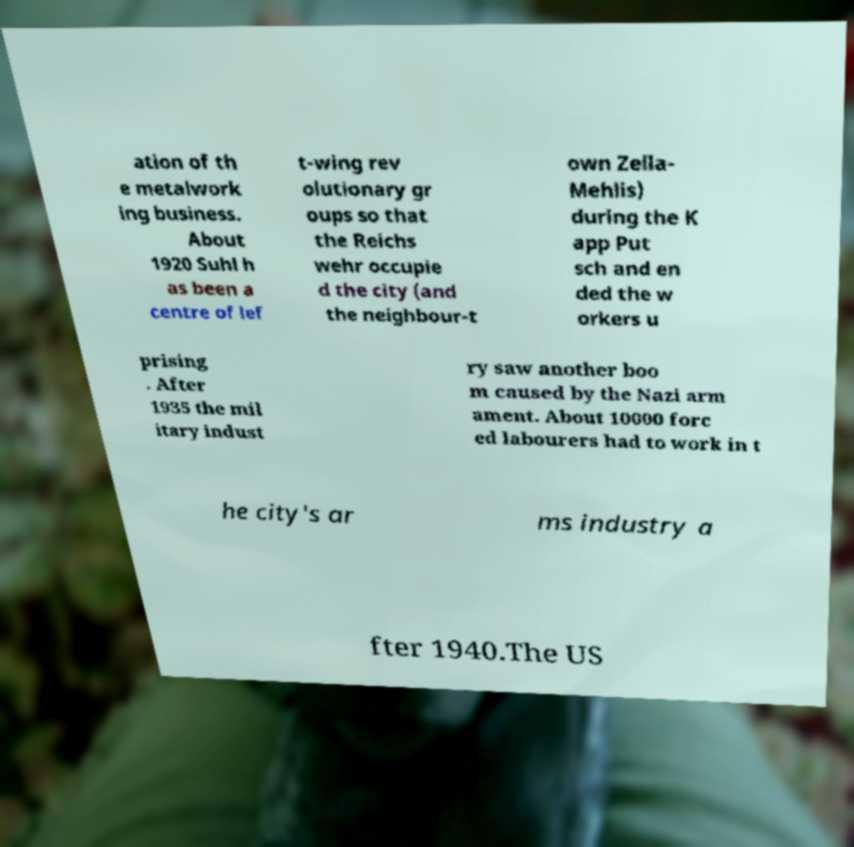Could you extract and type out the text from this image? ation of th e metalwork ing business. About 1920 Suhl h as been a centre of lef t-wing rev olutionary gr oups so that the Reichs wehr occupie d the city (and the neighbour-t own Zella- Mehlis) during the K app Put sch and en ded the w orkers u prising . After 1935 the mil itary indust ry saw another boo m caused by the Nazi arm ament. About 10000 forc ed labourers had to work in t he city's ar ms industry a fter 1940.The US 